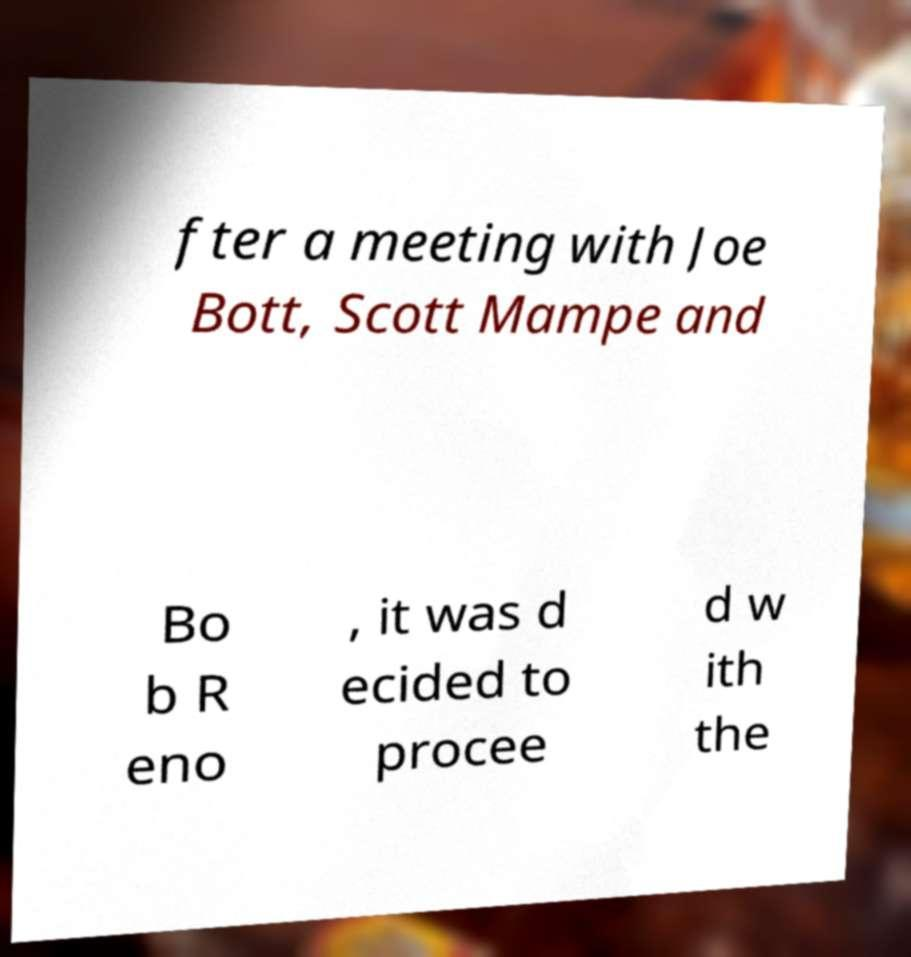There's text embedded in this image that I need extracted. Can you transcribe it verbatim? fter a meeting with Joe Bott, Scott Mampe and Bo b R eno , it was d ecided to procee d w ith the 